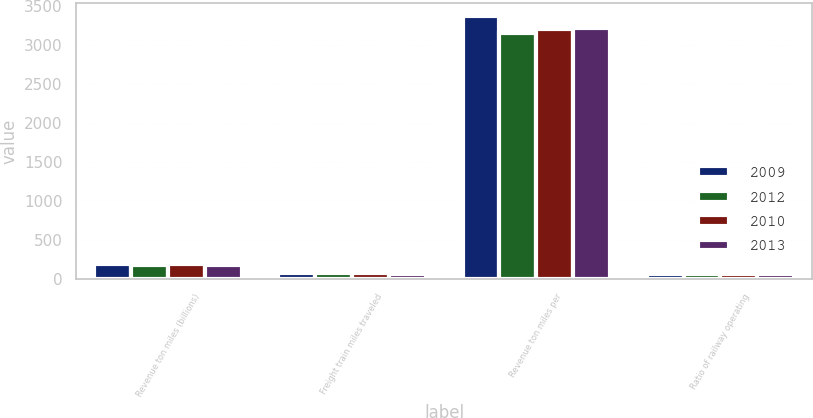Convert chart to OTSL. <chart><loc_0><loc_0><loc_500><loc_500><stacked_bar_chart><ecel><fcel>Revenue ton miles (billions)<fcel>Freight train miles traveled<fcel>Revenue ton miles per<fcel>Ratio of railway operating<nl><fcel>2009<fcel>194<fcel>74.8<fcel>3376<fcel>71<nl><fcel>2012<fcel>186<fcel>76.3<fcel>3153<fcel>71.7<nl><fcel>2010<fcel>192<fcel>75.7<fcel>3207<fcel>71.2<nl><fcel>2013<fcel>182<fcel>72.6<fcel>3218<fcel>71.9<nl></chart> 